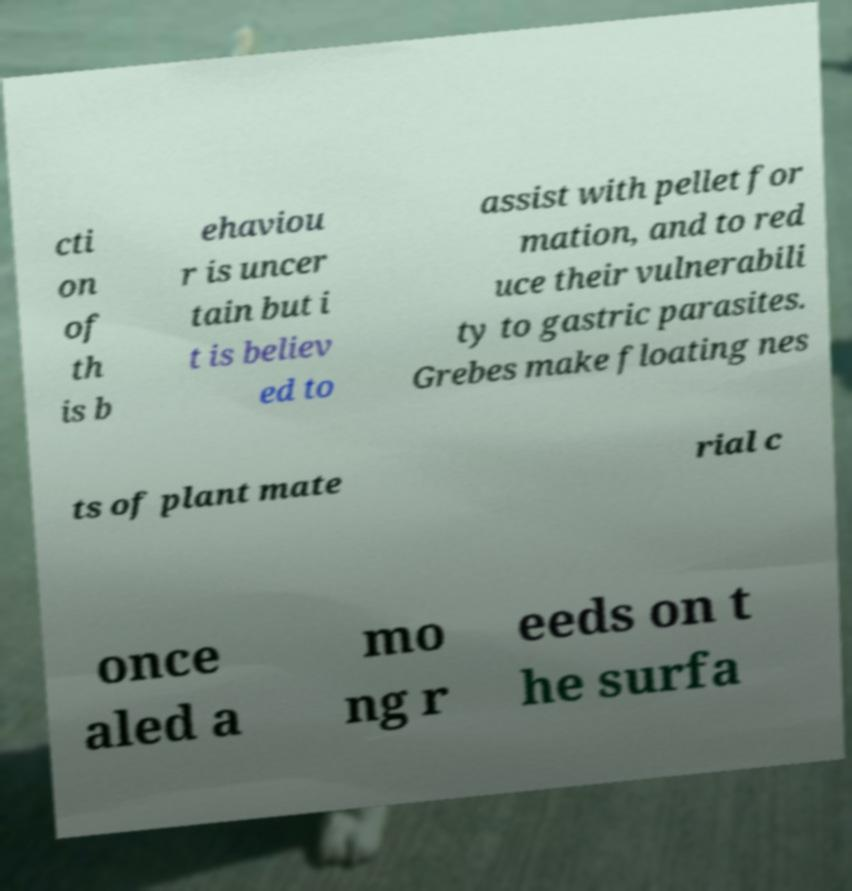There's text embedded in this image that I need extracted. Can you transcribe it verbatim? cti on of th is b ehaviou r is uncer tain but i t is believ ed to assist with pellet for mation, and to red uce their vulnerabili ty to gastric parasites. Grebes make floating nes ts of plant mate rial c once aled a mo ng r eeds on t he surfa 